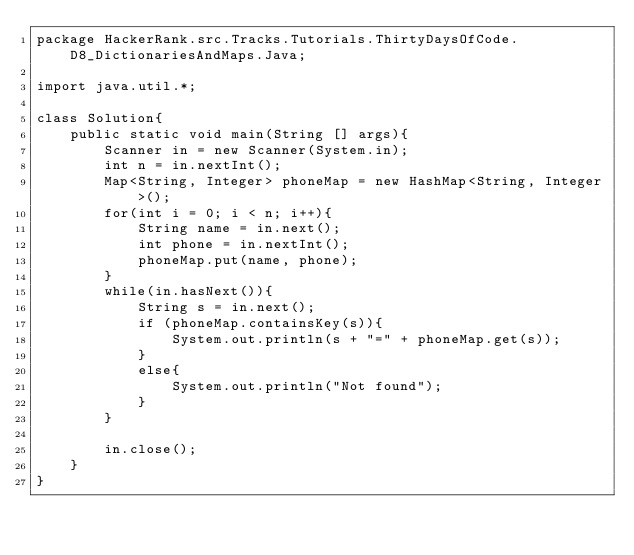Convert code to text. <code><loc_0><loc_0><loc_500><loc_500><_Java_>package HackerRank.src.Tracks.Tutorials.ThirtyDaysOfCode.D8_DictionariesAndMaps.Java;

import java.util.*;

class Solution{
    public static void main(String [] args){
        Scanner in = new Scanner(System.in);
        int n = in.nextInt();
        Map<String, Integer> phoneMap = new HashMap<String, Integer>(); 
        for(int i = 0; i < n; i++){
            String name = in.next();
            int phone = in.nextInt();
            phoneMap.put(name, phone);
        }
        while(in.hasNext()){
            String s = in.next();
            if (phoneMap.containsKey(s)){
                System.out.println(s + "=" + phoneMap.get(s));
            }
            else{
                System.out.println("Not found");
            }
        }
        
        in.close();
    }
}
</code> 